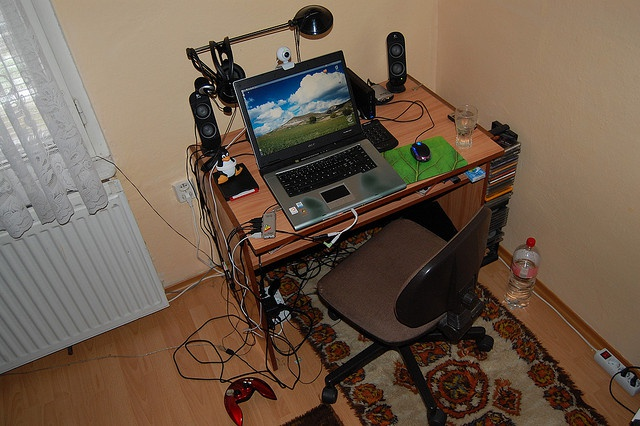Describe the objects in this image and their specific colors. I can see chair in gray, black, and maroon tones, laptop in gray, black, darkgray, and darkgreen tones, bottle in gray and maroon tones, cup in gray, brown, and tan tones, and mouse in gray, black, navy, and darkblue tones in this image. 